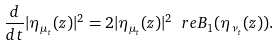<formula> <loc_0><loc_0><loc_500><loc_500>\frac { d } { d t } | \eta _ { \mu _ { t } } ( z ) | ^ { 2 } = 2 | \eta _ { \mu _ { t } } ( z ) | ^ { 2 } \ r e B _ { 1 } ( \eta _ { \nu _ { t } } ( z ) ) .</formula> 